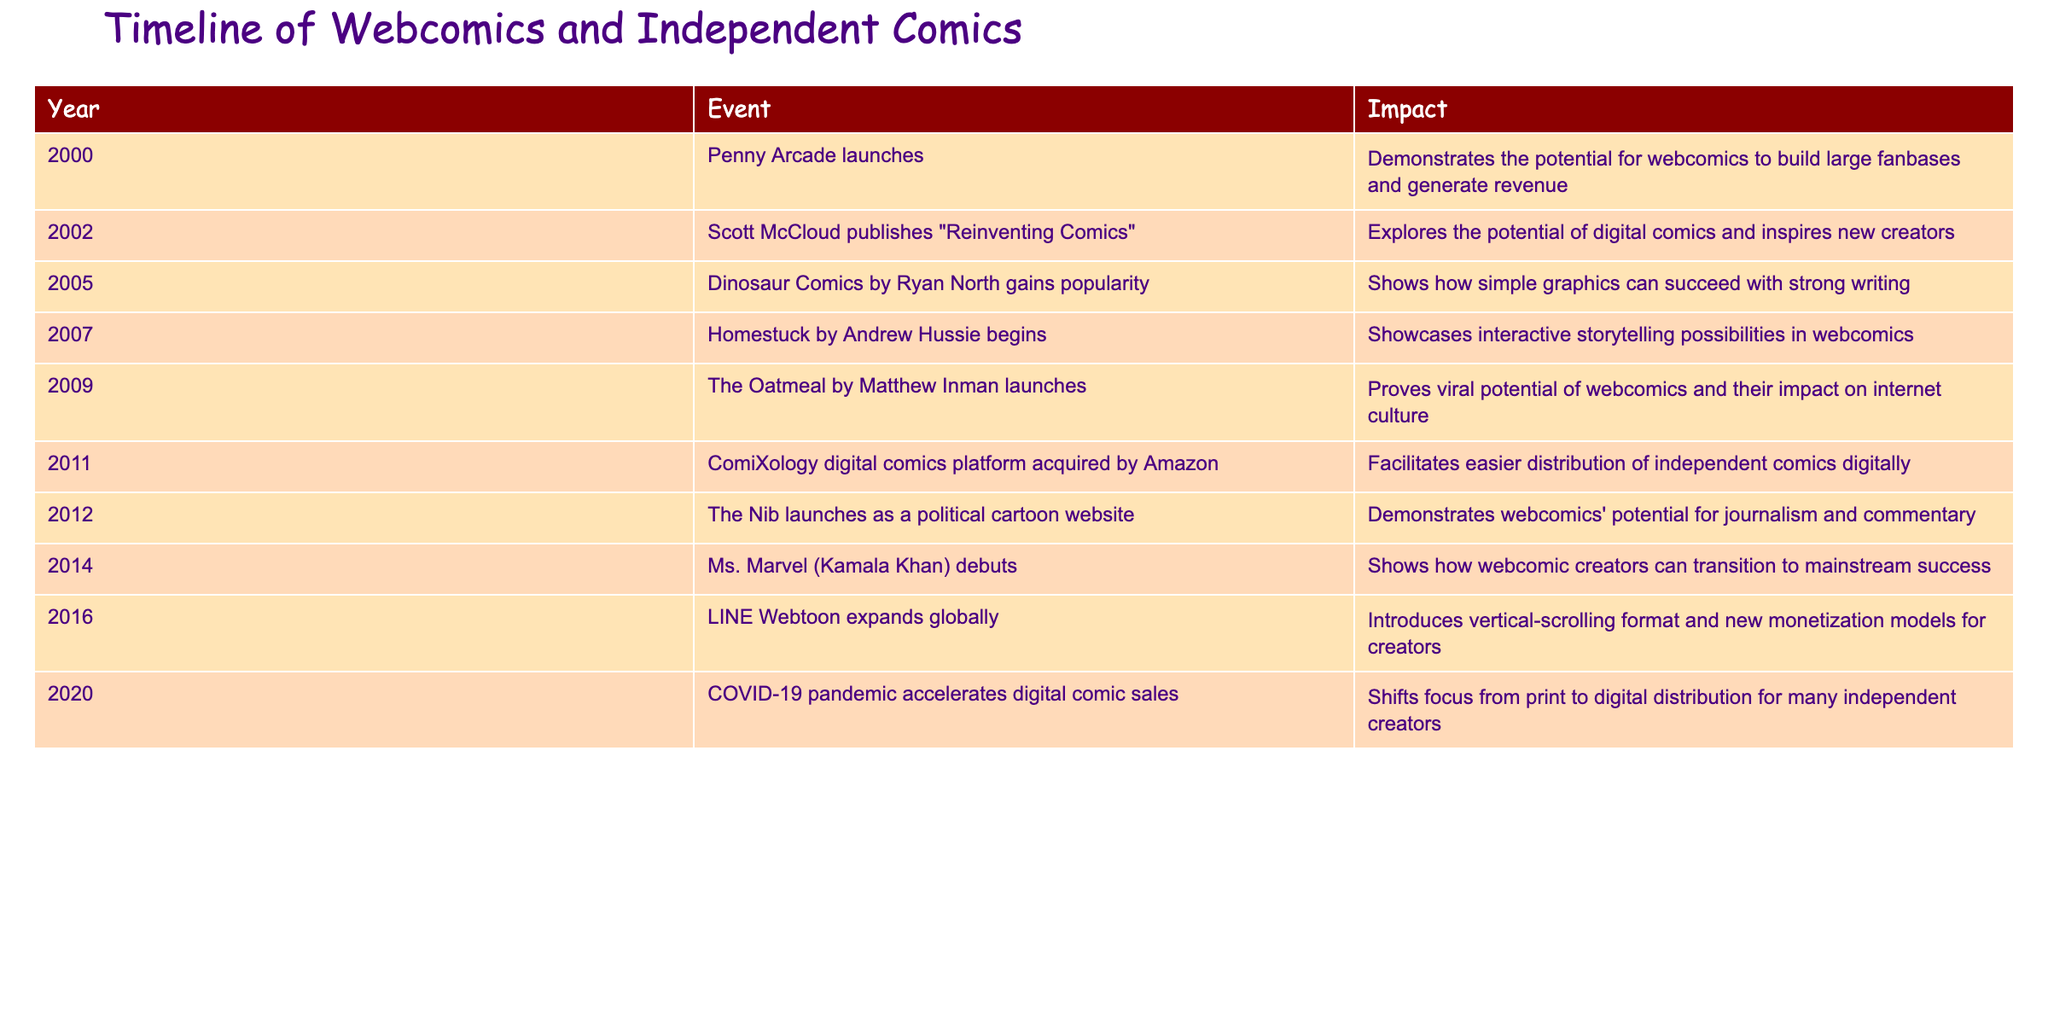What year did Penny Arcade launch? The table lists the events in chronological order from 2000 onwards. According to the first entry, Penny Arcade launched in the year 2000.
Answer: 2000 Which event had the impact of demonstrating webcomics' potential for journalism and commentary? In the table, we can find that "The Nib launches as a political cartoon website" in 2012 is the event that specifically mentions its potential for journalism and commentary.
Answer: The Nib launches as a political cartoon website How many years apart are the launches of The Oatmeal and ComiXology? The Oatmeal launched in 2009, and ComiXology was acquired by Amazon in 2011. Subtracting the years gives 2011 - 2009 = 2 years apart.
Answer: 2 Did any webcomic launch in 2007? Referring to the table, we check the year 2007 and find that Homestuck by Andrew Hussie began in that year, confirming that a webcomic did launch.
Answer: Yes What is the average year of the events listed in the table? To calculate the average, we add the years: 2000 + 2002 + 2005 + 2007 + 2009 + 2011 + 2012 + 2014 + 2016 + 2020 = 2010. Dividing by the number of events (10) gives us an average of 2010.
Answer: 2010 Which event marks a shift in focus from print to digital distribution? The event that shows this transition is the 2020 entry, where it states that the COVID-19 pandemic accelerated digital comic sales, indicating the shift to digital.
Answer: COVID-19 pandemic accelerates digital comic sales How many events listed describe the impact of webcomics on revenue generation? The first event in 2000 states that Penny Arcade demonstrates the potential for webcomics to generate revenue. The sixth entry in 2016 mentions new monetization models, making a total of 2 events that discuss revenue generation.
Answer: 2 Was the debut of Ms. Marvel in 2014 significant for independent creators? The table indicates that the debut of Ms. Marvel (Kamala Khan) showcases how webcomic creators can transition to mainstream success, confirming its significance for independent creators.
Answer: Yes What event came after LINE Webtoon expanded globally? Referring to the table, the event that follows LINE Webtoon expanding globally in 2016 is the COVID-19 pandemic accelerating digital comic sales in 2020.
Answer: COVID-19 pandemic accelerates digital comic sales 